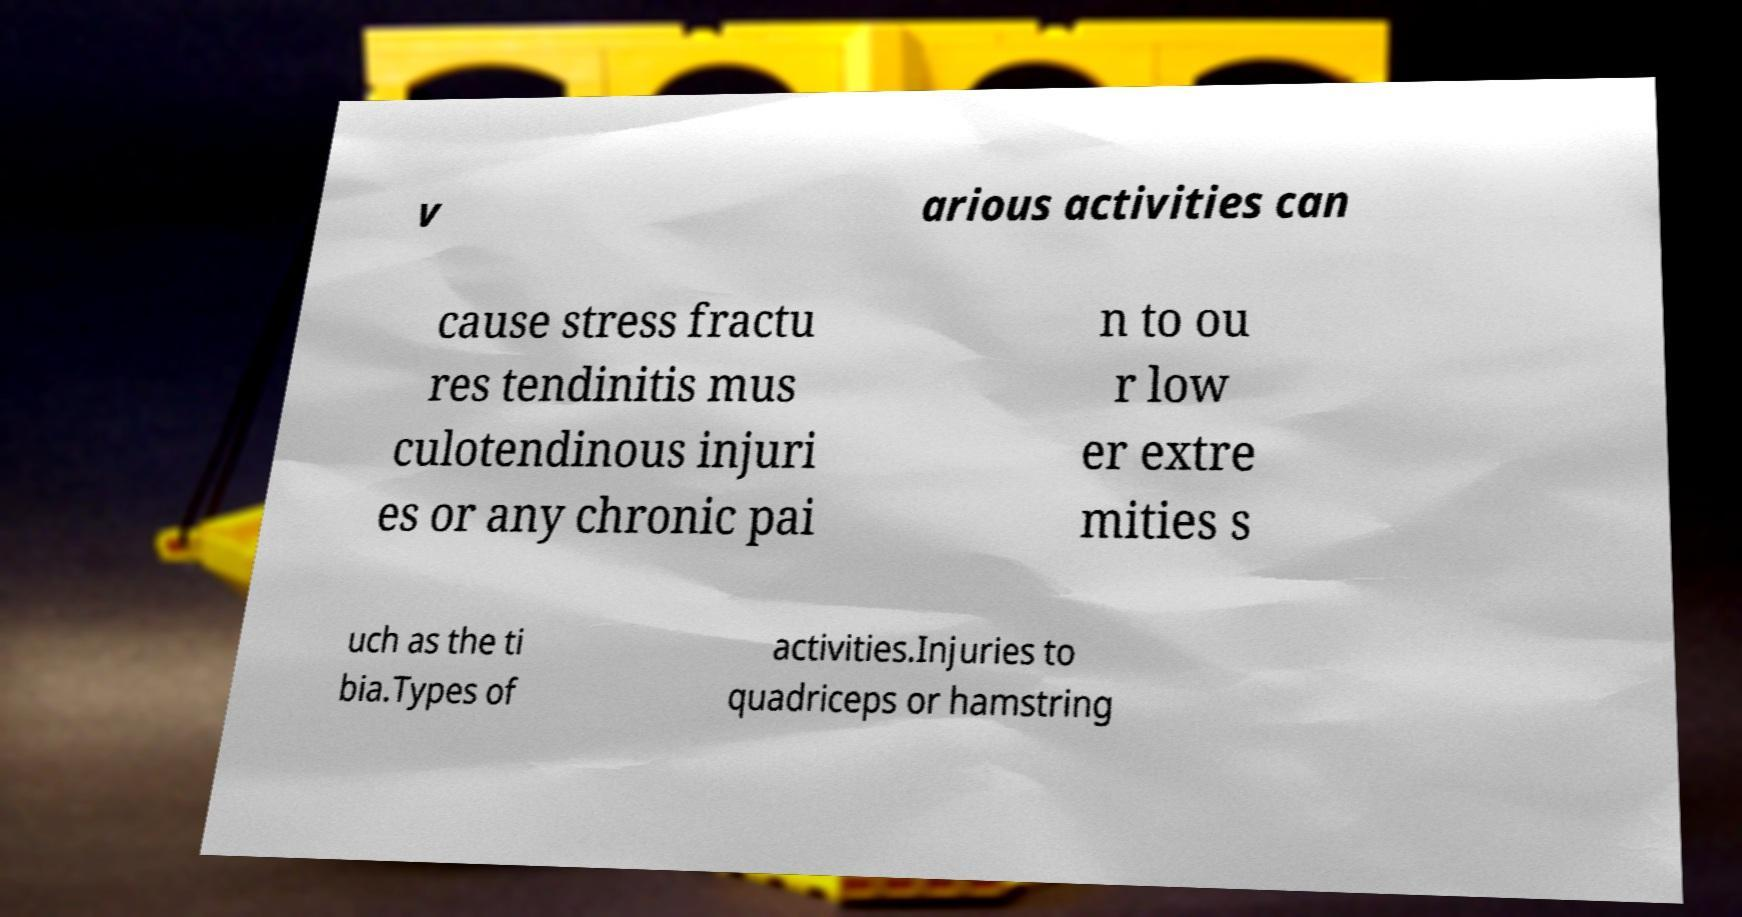Please read and relay the text visible in this image. What does it say? v arious activities can cause stress fractu res tendinitis mus culotendinous injuri es or any chronic pai n to ou r low er extre mities s uch as the ti bia.Types of activities.Injuries to quadriceps or hamstring 